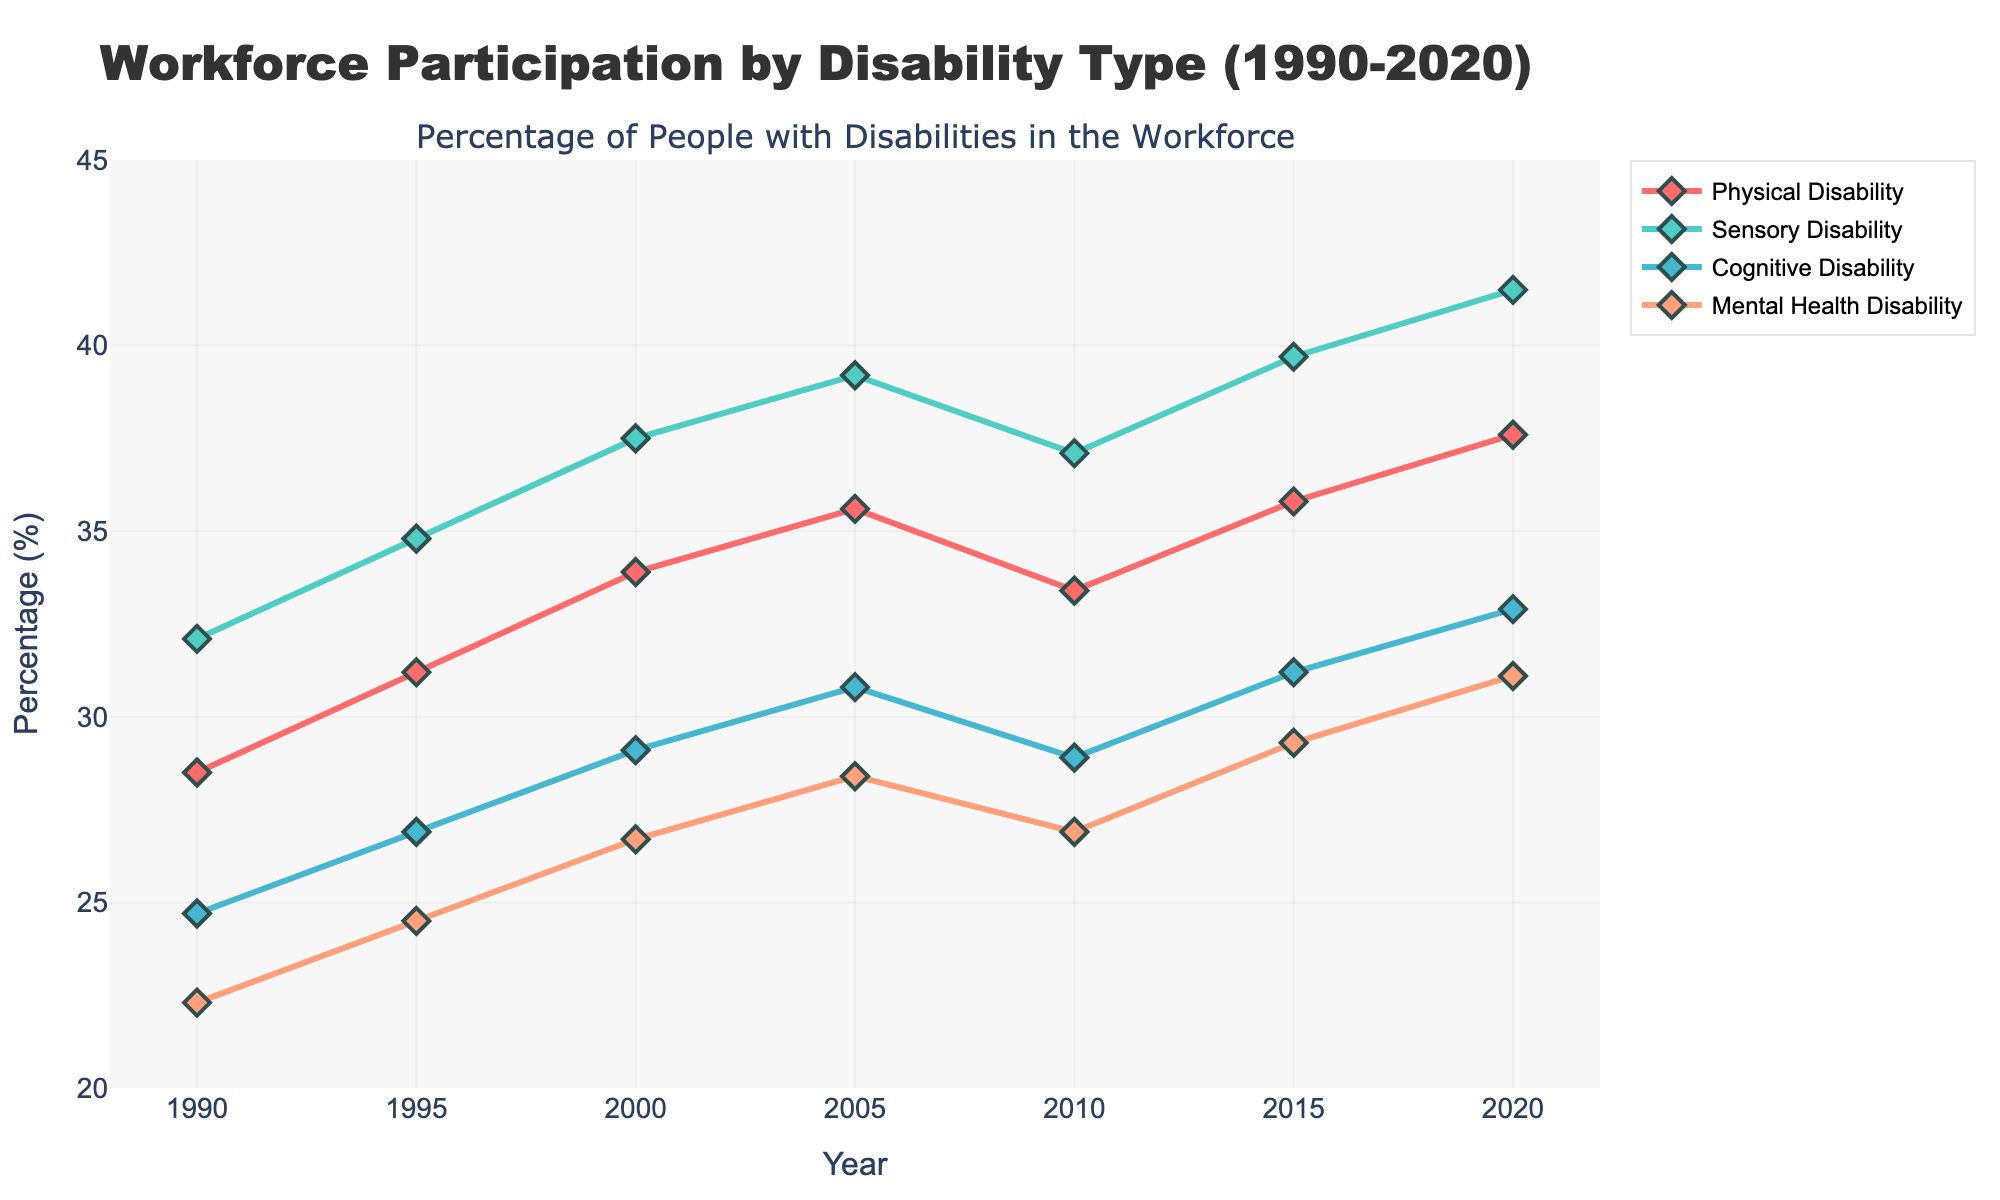what is the largest percentage increase for any disability type over a five-year period? To find the largest percentage increase, we need to calculate the difference for each disability type across all five-year intervals provided. For Physical Disability, the largest increase occurs between 2015 and 2020 (37.6 - 35.8 = 1.8). For Sensory Disability, the largest increase occurs between 2015 and 2020 (41.5 - 39.7 = 1.8). For Cognitive Disability, the largest increase occurs between 2015 and 2020 (32.9 - 31.2 = 1.7). For Mental Health Disability, the largest increase occurs between 2015 and 2020 (31.1 - 29.3 = 1.8). The largest increase for any disability type over a five-year period is therefore 1.8 percentage points.
Answer: 1.8 which disability type had the highest workforce participation in 2010? To determine which disability type had the highest workforce participation in 2010, we compare the values for each type in that year. Physical Disability is 33.4, Sensory Disability is 37.1, Cognitive Disability is 28.9, and Mental Health Disability is 26.9. Sensory Disability had the highest workforce participation in 2010.
Answer: Sensory Disability how much did workforce participation for Physical Disability change from 1990 to 2020? To find the change in workforce participation for Physical Disability from 1990 to 2020, subtract the 1990 value from the 2020 value. In 1990, it was 28.5, and in 2020, it was 37.6. The change is 37.6 - 28.5 = 9.1 percentage points.
Answer: 9.1 which disability type consistently showed an increase over the 30-year period? To identify the disability type that consistently showed an increase, check each interval's value for gradual increases. Physical Disability increased from 28.5 in 1990 to 37.6 in 2020, showing a general upward trend. Sensory Disability similarly increased from 32.1 to 41.5. Cognitive Disability and Mental Health Disability had decreases at certain points over the years. Thus, both Physical Disability and Sensory Disability consistently showed an increase.
Answer: Physical Disability and Sensory Disability which year showed the lowest workforce participation in Mental Health Disability? From the data, compare the workforce participation of Mental Health Disability for each year. The values are 22.3 (1990), 24.5 (1995), 26.7 (2000), 28.4 (2005), 26.9 (2010), 29.3 (2015), and 31.1 (2020). The lowest workforce participation for Mental Health Disability was in 1990.
Answer: 1990 what was the difference in participation between Sensory Disability and Cognitive Disability in 2000? To find the difference in workforce participation between Sensory Disability and Cognitive Disability in 2000, subtract the value of Cognitive Disability from Sensory Disability. In 2000, Sensory Disability was 37.5, and Cognitive Disability was 29.1. The difference is 37.5 - 29.1 = 8.4 percentage points.
Answer: 8.4 which disability type had the most fluctuating workforce participation throughout the 30-year period? To determine the most fluctuating disability type, observe the changes in workforce participation values at each interval for all disabilities over the 30-year period. Physical Disability, Sensory Disability, and Cognitive Disability generally followed a gradual trend. Mental Health Disability exhibited fluctuations, especially between the years 2005 (28.4), 2010 (26.9), and 2015 (29.3). Thus, Mental Health Disability had the most fluctuating workforce participation.
Answer: Mental Health Disability between which two consecutive years did Sensory Disability see the smallest increase in workforce participation? To determine the smallest increase for Sensory Disability, compute the differences for each consecutive year in the data. From 1990 to 1995, the increase was 34.8 - 32.1 = 2.7. From 1995 to 2000, the increase was 37.5 - 34.8 = 2.7. From 2000 to 2005, the increase was 39.2 - 37.5 = 1.7. From 2005 to 2010, the increase was 37.1 - 39.2 = -2.1 (which is a decrease). From 2010 to 2015, the increase was 39.7 - 37.1 = 2.6. From 2015 to 2020, the increase was 41.5 - 39.7 = 1.8. Therefore, the smallest increase (excluding the decrease) is between 2000 and 2005.
Answer: 2000 and 2005 